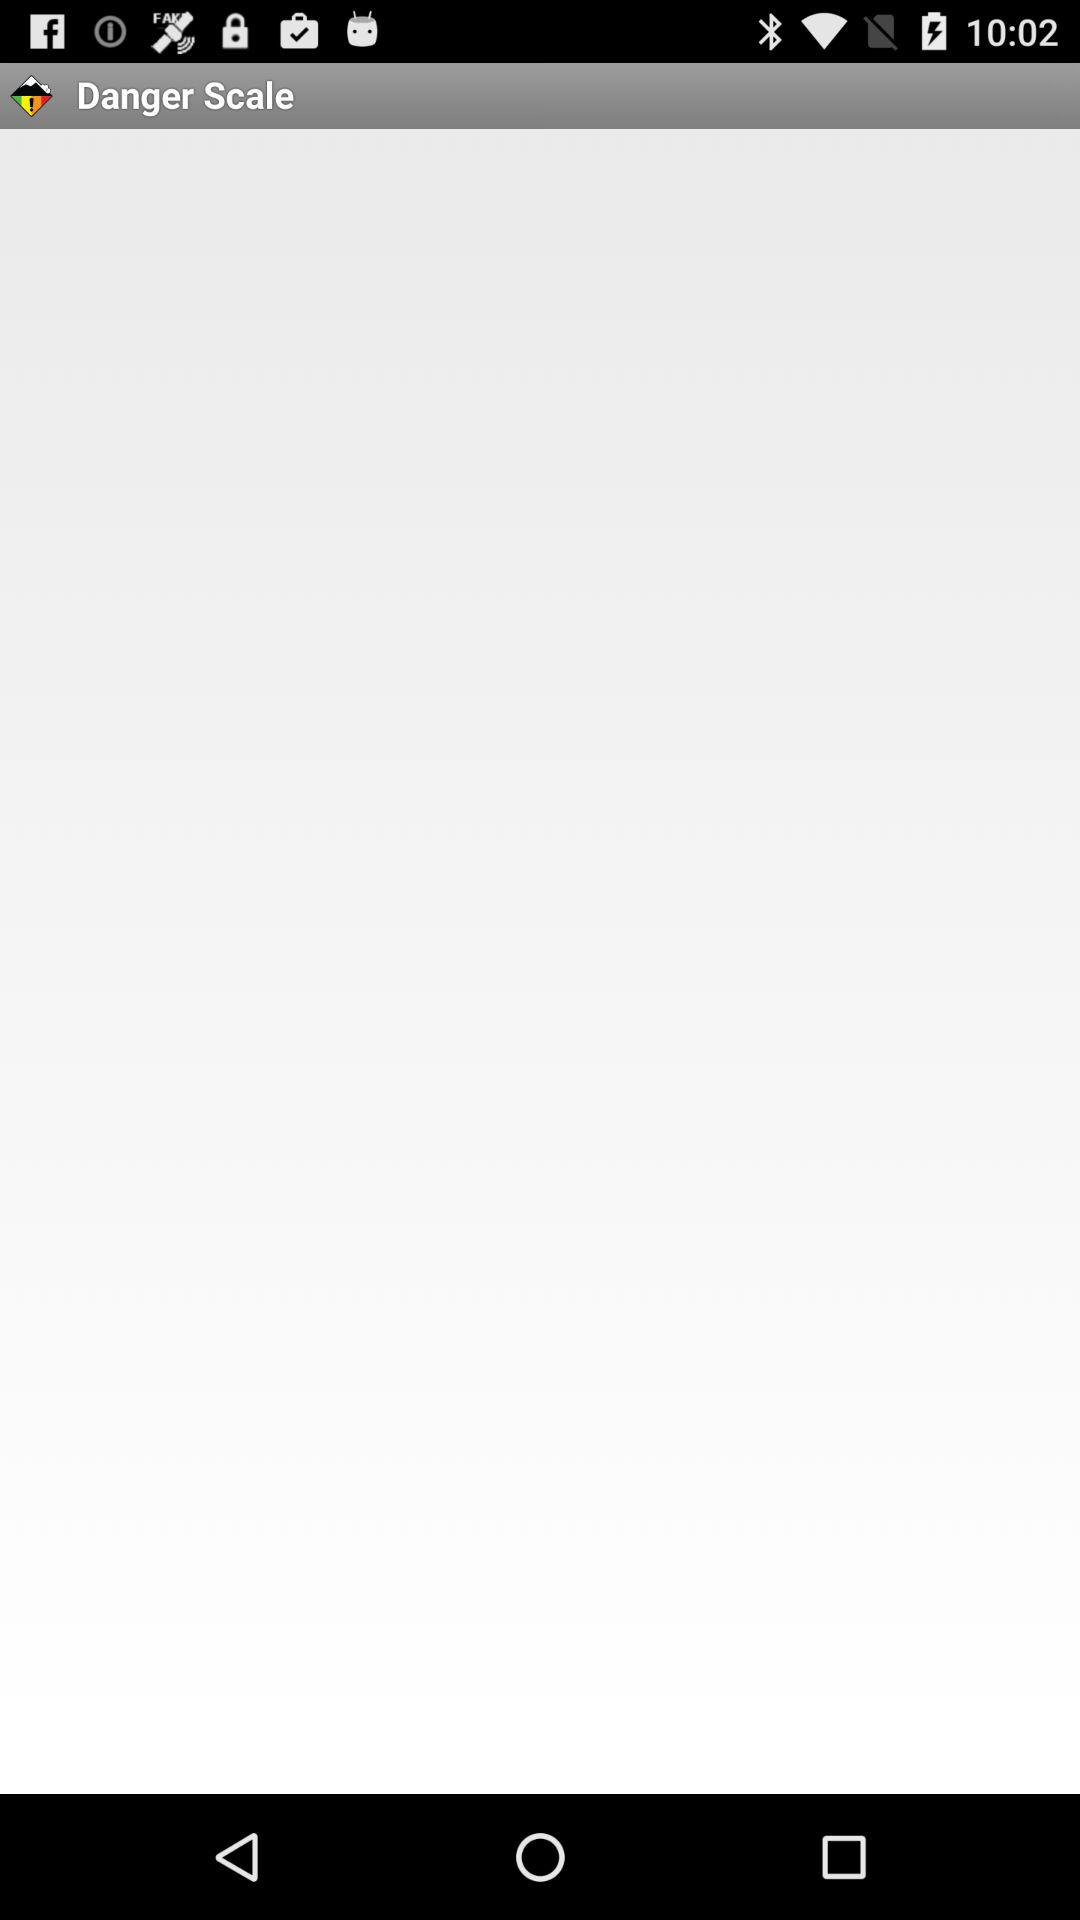What is the name of the application? The name of the application is "Danger Scale". 